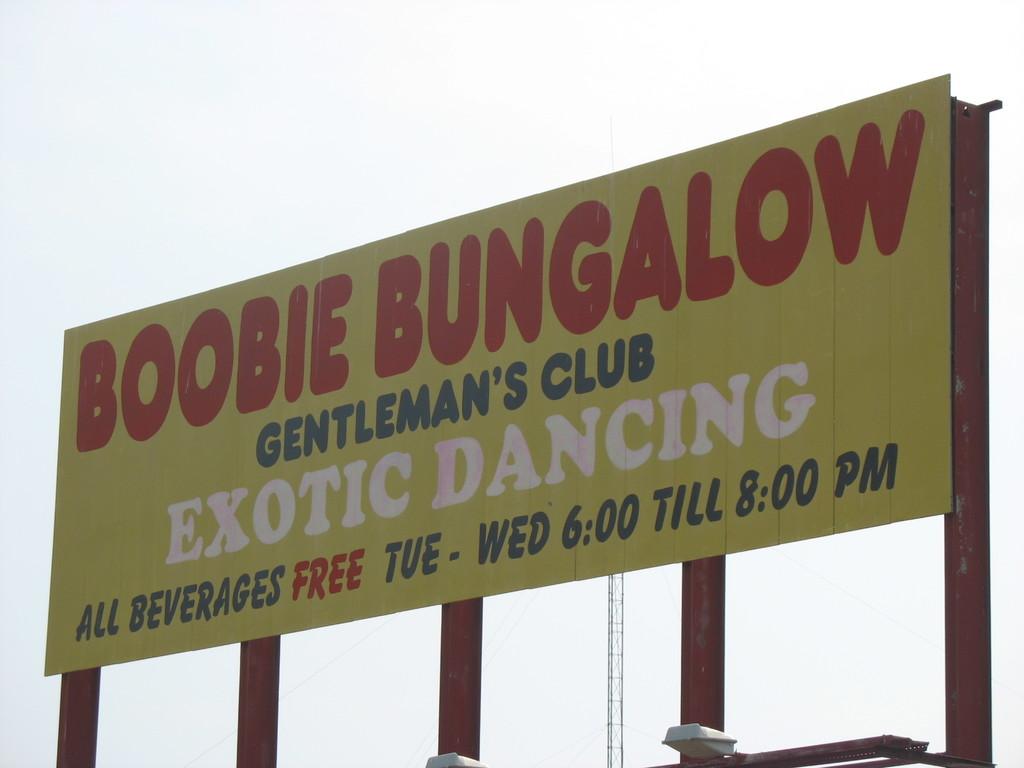How much are beverages?
Offer a very short reply. Free. 